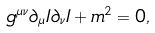Convert formula to latex. <formula><loc_0><loc_0><loc_500><loc_500>g ^ { \mu \nu } \partial _ { \mu } I \partial _ { \nu } I + m ^ { 2 } = 0 ,</formula> 